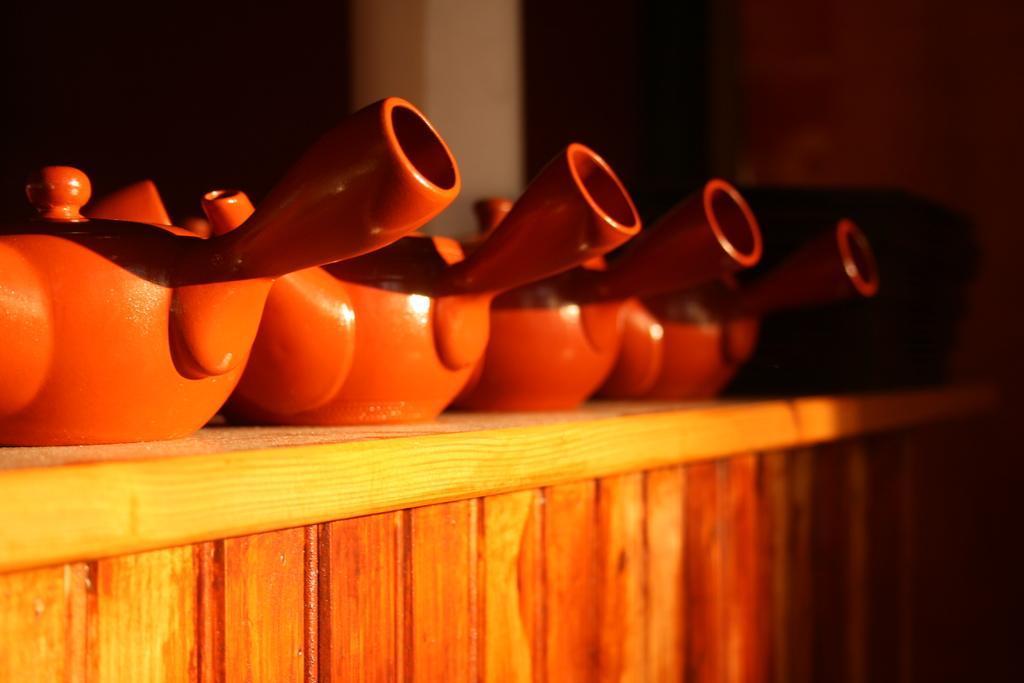In one or two sentences, can you explain what this image depicts? This image is taken indoors. In the background there is a wall. At the bottom of the image there is a wooden table with a few kettles and a basket on it. 